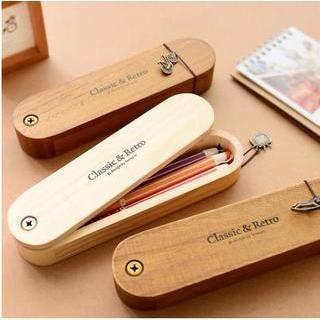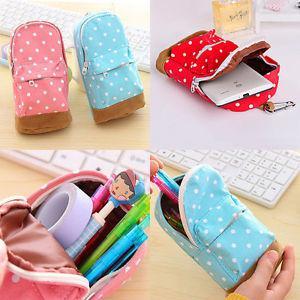The first image is the image on the left, the second image is the image on the right. For the images displayed, is the sentence "An open pencil case contains at least one stick-shaped item with a cartoony face shape on the end." factually correct? Answer yes or no. Yes. The first image is the image on the left, the second image is the image on the right. Evaluate the accuracy of this statement regarding the images: "A person is holding a pencil case with one hand in the image on the left.". Is it true? Answer yes or no. No. 